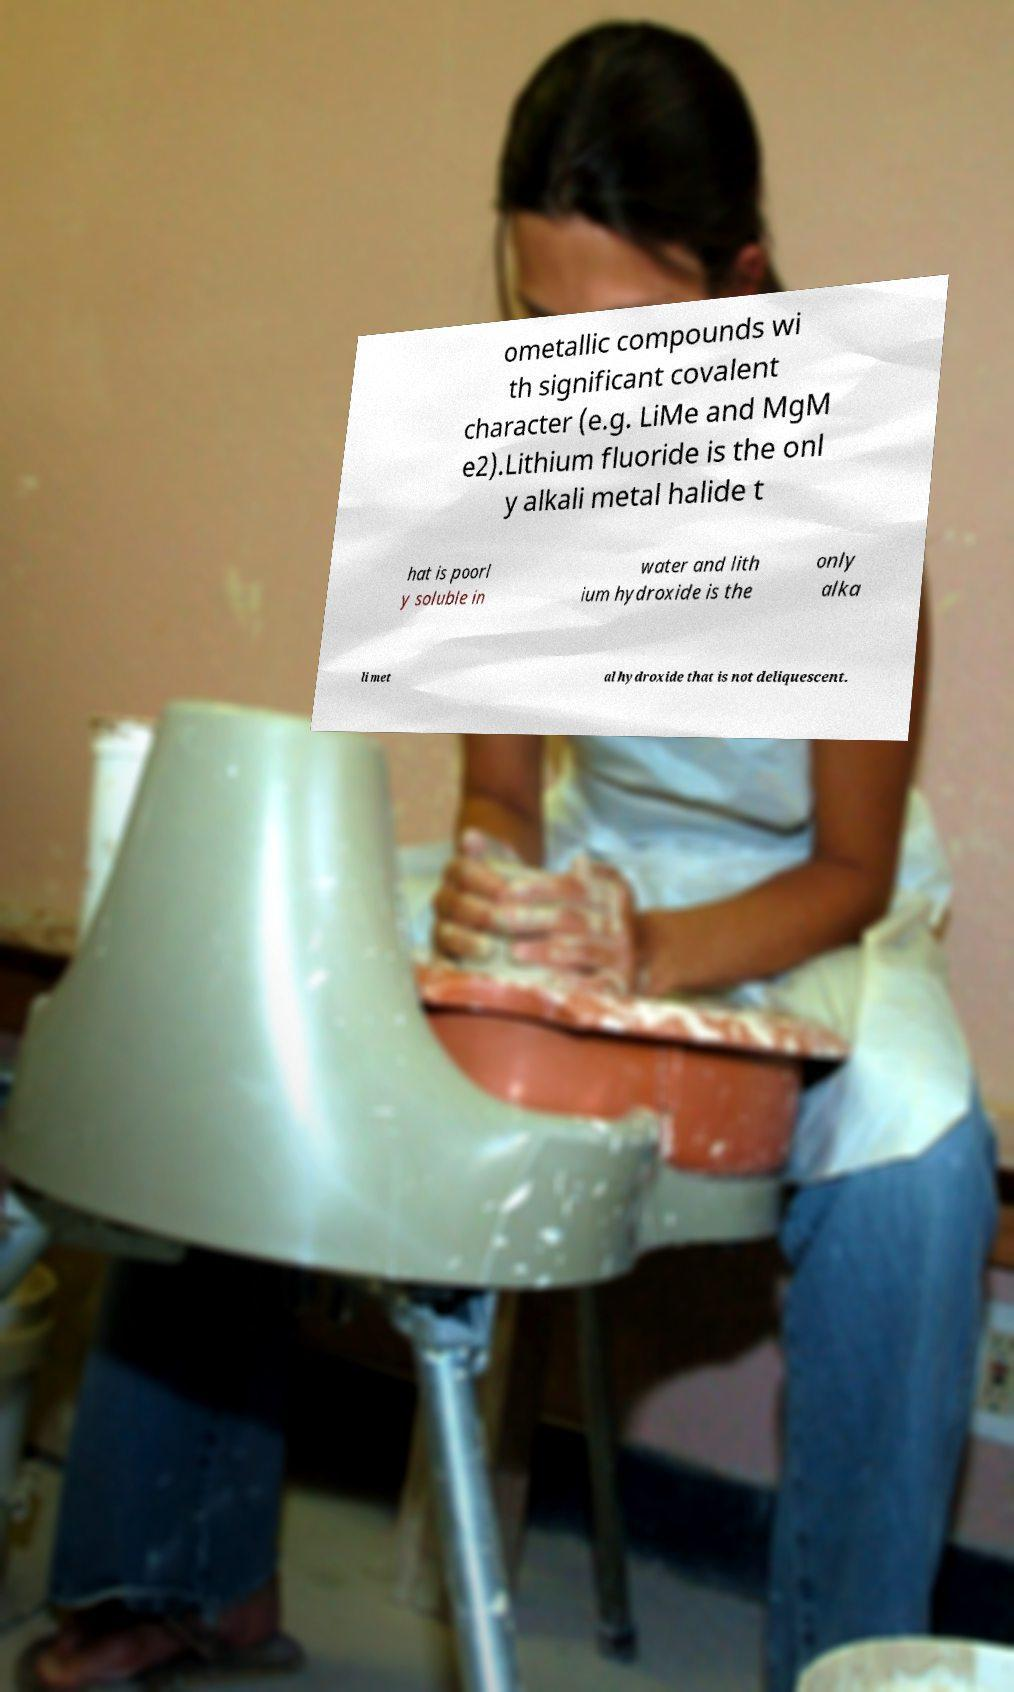Please read and relay the text visible in this image. What does it say? ometallic compounds wi th significant covalent character (e.g. LiMe and MgM e2).Lithium fluoride is the onl y alkali metal halide t hat is poorl y soluble in water and lith ium hydroxide is the only alka li met al hydroxide that is not deliquescent. 